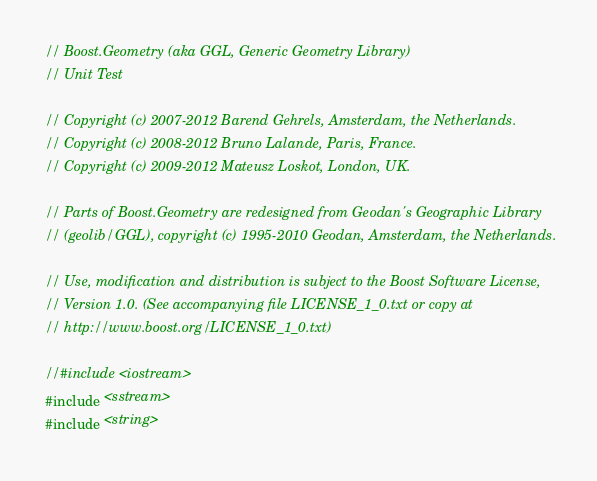<code> <loc_0><loc_0><loc_500><loc_500><_C++_>// Boost.Geometry (aka GGL, Generic Geometry Library)
// Unit Test

// Copyright (c) 2007-2012 Barend Gehrels, Amsterdam, the Netherlands.
// Copyright (c) 2008-2012 Bruno Lalande, Paris, France.
// Copyright (c) 2009-2012 Mateusz Loskot, London, UK.

// Parts of Boost.Geometry are redesigned from Geodan's Geographic Library
// (geolib/GGL), copyright (c) 1995-2010 Geodan, Amsterdam, the Netherlands.

// Use, modification and distribution is subject to the Boost Software License,
// Version 1.0. (See accompanying file LICENSE_1_0.txt or copy at
// http://www.boost.org/LICENSE_1_0.txt)

//#include <iostream>
#include <sstream>
#include <string>
</code> 